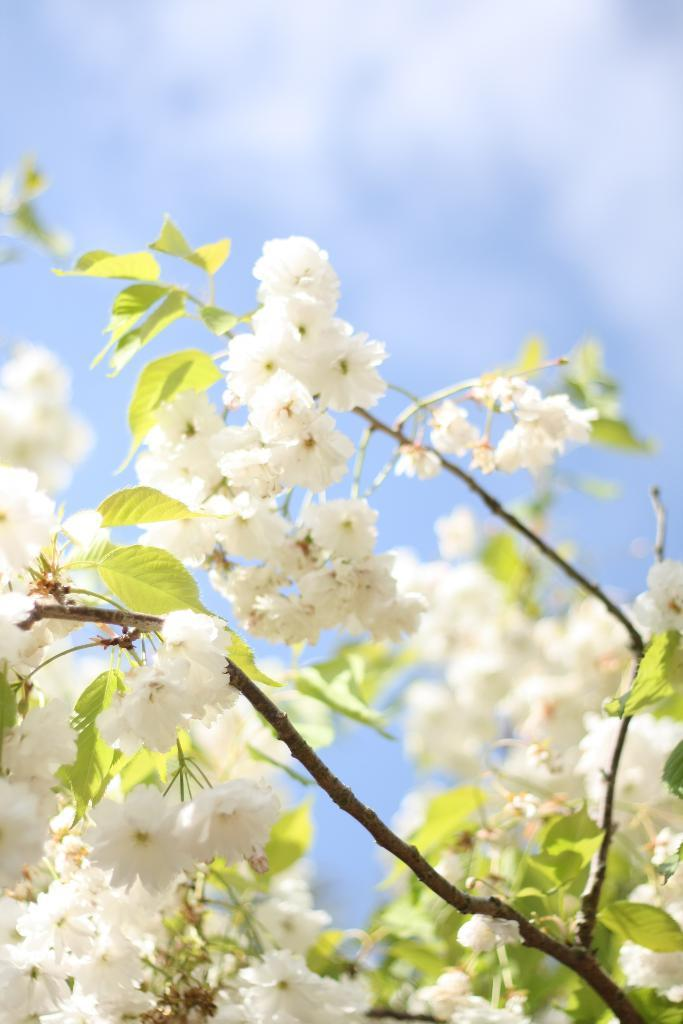What type of flowers are present in the image? There are white color flowers in the image. What other parts of the plants can be seen besides the flowers? There are leaves and stems in the image. What type of skirt is being worn by the star in the image? There is no skirt or star present in the image; it features white color flowers, leaves, and stems. 